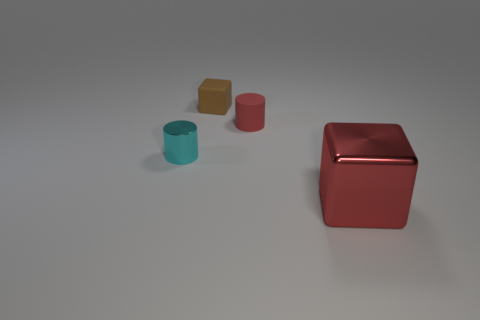Can you describe the lighting in the image? The image shows a soft, diffuse light source, creating gentle shadows and subtle highlights on the objects without harsh contrasts. 